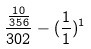<formula> <loc_0><loc_0><loc_500><loc_500>\frac { \frac { 1 0 } { 3 5 6 } } { 3 0 2 } - ( \frac { 1 } { 1 } ) ^ { 1 }</formula> 